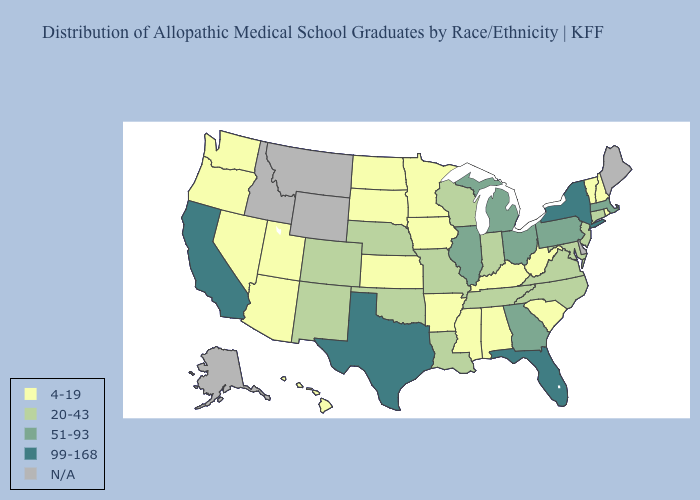What is the lowest value in the USA?
Keep it brief. 4-19. Which states have the lowest value in the USA?
Keep it brief. Alabama, Arizona, Arkansas, Hawaii, Iowa, Kansas, Kentucky, Minnesota, Mississippi, Nevada, New Hampshire, North Dakota, Oregon, Rhode Island, South Carolina, South Dakota, Utah, Vermont, Washington, West Virginia. Does Arkansas have the highest value in the USA?
Write a very short answer. No. Name the states that have a value in the range N/A?
Quick response, please. Alaska, Delaware, Idaho, Maine, Montana, Wyoming. Name the states that have a value in the range 99-168?
Answer briefly. California, Florida, New York, Texas. Name the states that have a value in the range 51-93?
Give a very brief answer. Georgia, Illinois, Massachusetts, Michigan, Ohio, Pennsylvania. What is the highest value in the USA?
Quick response, please. 99-168. Which states have the lowest value in the Northeast?
Concise answer only. New Hampshire, Rhode Island, Vermont. Does New Mexico have the lowest value in the USA?
Answer briefly. No. What is the highest value in states that border Minnesota?
Be succinct. 20-43. Name the states that have a value in the range 4-19?
Be succinct. Alabama, Arizona, Arkansas, Hawaii, Iowa, Kansas, Kentucky, Minnesota, Mississippi, Nevada, New Hampshire, North Dakota, Oregon, Rhode Island, South Carolina, South Dakota, Utah, Vermont, Washington, West Virginia. Which states have the lowest value in the USA?
Write a very short answer. Alabama, Arizona, Arkansas, Hawaii, Iowa, Kansas, Kentucky, Minnesota, Mississippi, Nevada, New Hampshire, North Dakota, Oregon, Rhode Island, South Carolina, South Dakota, Utah, Vermont, Washington, West Virginia. Name the states that have a value in the range N/A?
Keep it brief. Alaska, Delaware, Idaho, Maine, Montana, Wyoming. What is the value of Colorado?
Give a very brief answer. 20-43. 